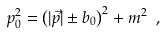<formula> <loc_0><loc_0><loc_500><loc_500>p _ { 0 } ^ { 2 } = \left ( | \vec { p } | \pm b _ { 0 } \right ) ^ { 2 } + m ^ { 2 } \ ,</formula> 